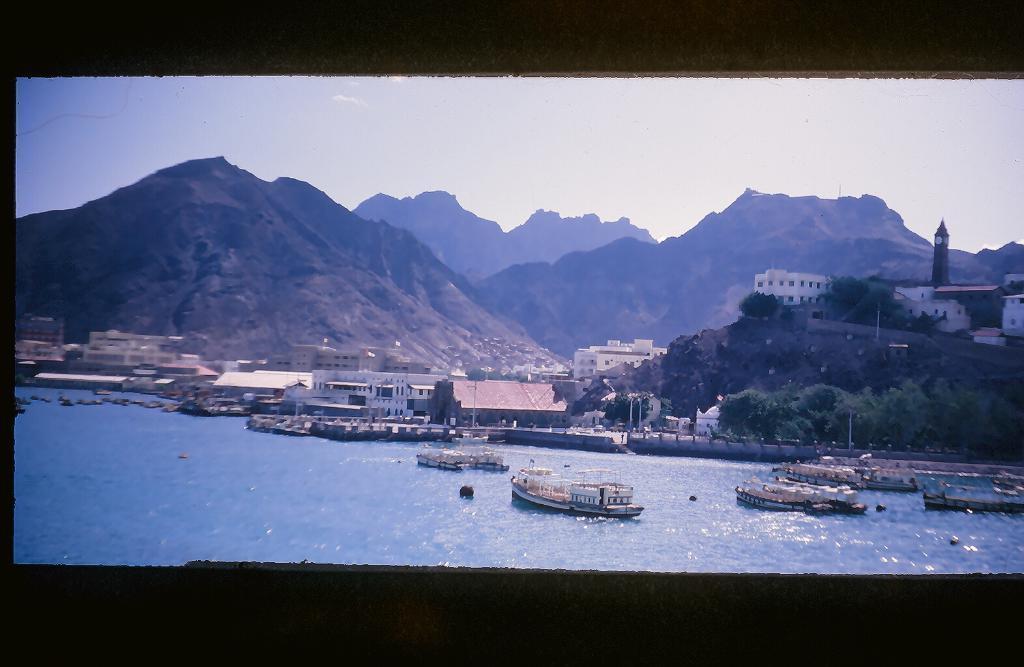Describe this image in one or two sentences. In this image we can see a screen. There are many buildings in the image. There are many trees at the right side of the image. We can see the sea in the image. There are few mountains in the image. There are few watercraft in the image. We can see the sky in the image. 